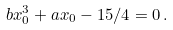<formula> <loc_0><loc_0><loc_500><loc_500>b x _ { 0 } ^ { 3 } + a x _ { 0 } - 1 5 / 4 = 0 \, .</formula> 